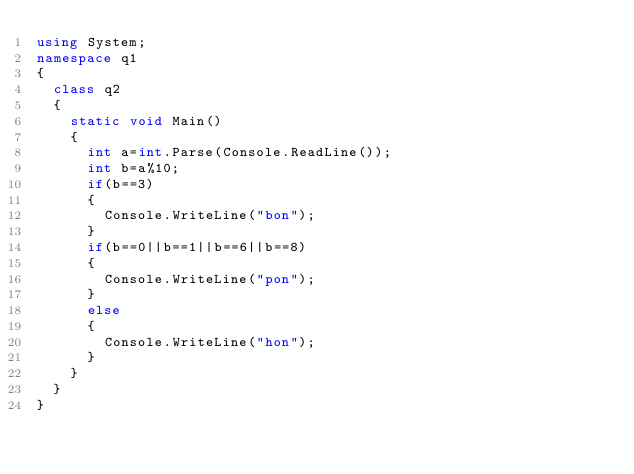<code> <loc_0><loc_0><loc_500><loc_500><_C#_>using System;
namespace q1
{
  class q2
  {
    static void Main()
    {
      int a=int.Parse(Console.ReadLine());
      int b=a%10;
      if(b==3)
      {
        Console.WriteLine("bon");
      }
      if(b==0||b==1||b==6||b==8)
      {
        Console.WriteLine("pon");
      }
      else
      {
        Console.WriteLine("hon");
      }
    }
  }
}
</code> 